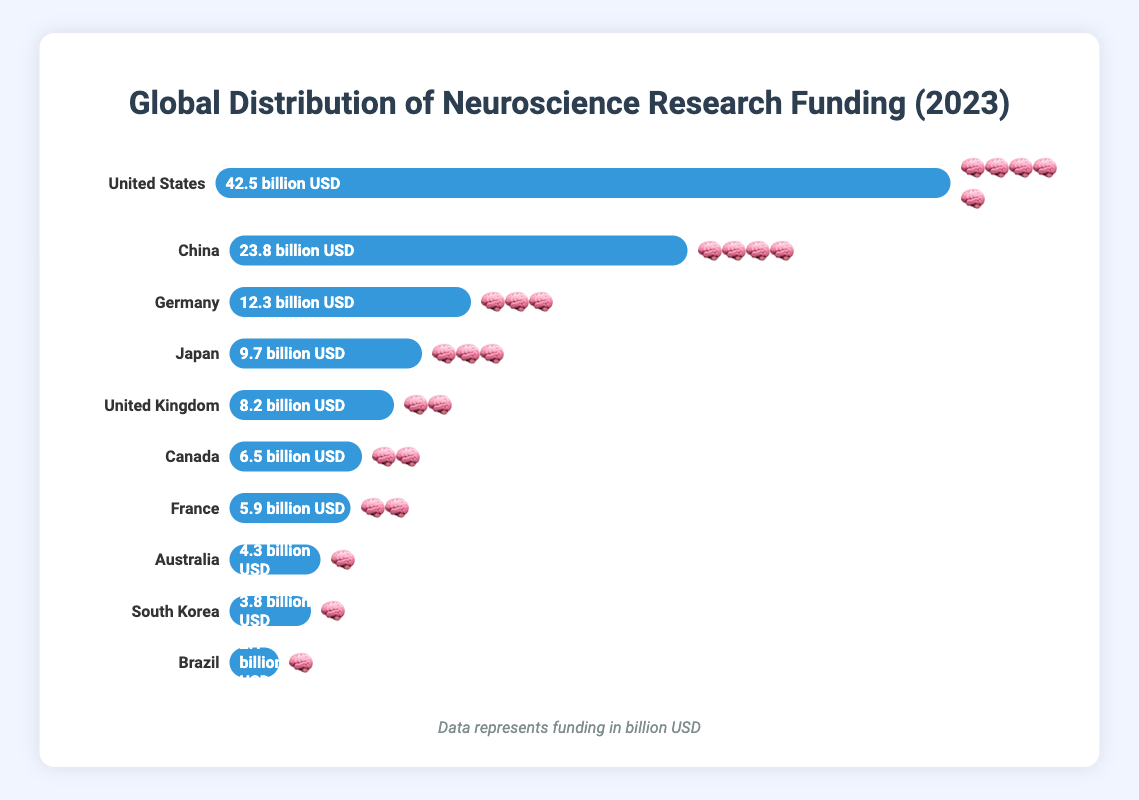What is the title of the figure? The title is located at the top center of the figure in bold text and indicates the main topic.
Answer: Global Distribution of Neuroscience Research Funding (2023) Which country has the highest neuroscience research funding? The country with the longest blue bar and the largest number of brain emojis has the highest funding.
Answer: United States What is the total neuroscience research funding of Germany and Japan combined? Add the funding values for Germany (12.3 billion USD) and Japan (9.7 billion USD).
Answer: 22.0 billion USD How many brain emojis represent the funding level of China? Count the number of brain emojis next to China's funding bar.
Answer: 4 Which country has the smallest neuroscience research funding? The country with the shortest blue bar and the smallest number of brain emojis has the smallest funding.
Answer: Brazil How does Canada’s research funding compare to that of Australia? Compare the width of Canada's funding bar to Australia's funding bar and the number of brain emojis for each.
Answer: Canada has more funding than Australia What is the difference in research funding between the United States and China? Subtract China's funding (23.8 billion USD) from the United States' funding (42.5 billion USD).
Answer: 18.7 billion USD Arrange the countries listed in order from highest to lowest research funding. List the countries based on the length of their blue bars and the number of brain emojis, starting with the United States.
Answer: United States, China, Germany, Japan, United Kingdom, Canada, France, Australia, South Korea, Brazil What is the average neuroscience research funding among the top three countries? Add the funding amounts of the United States, China, and Germany, then divide by 3. (42.5 + 23.8 + 12.3) / 3.
Answer: 26.2 billion USD 